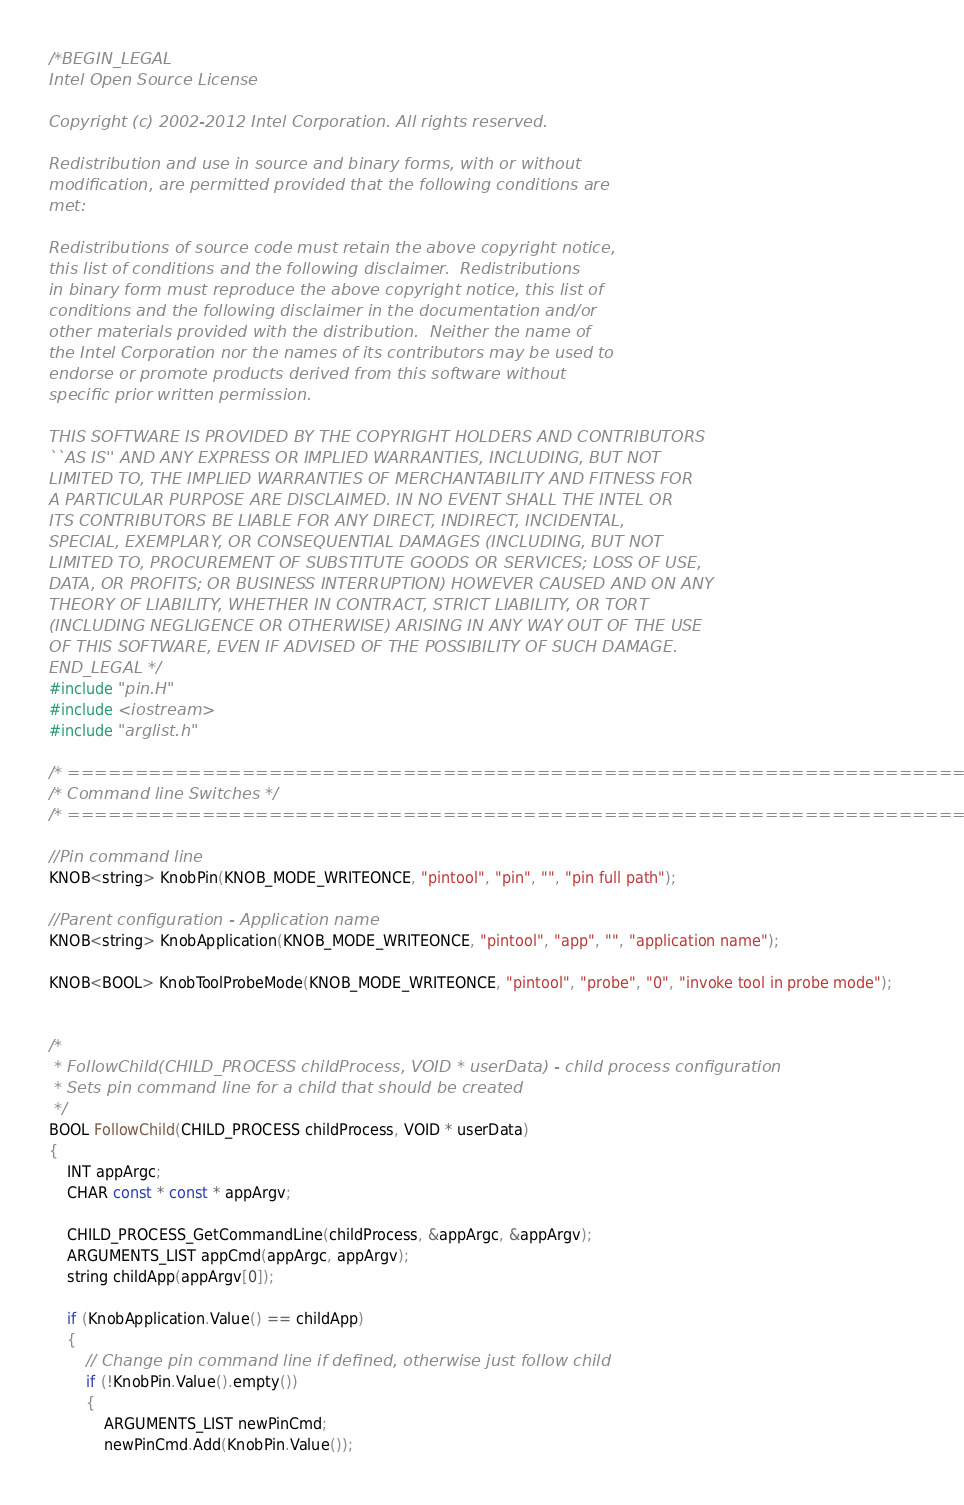<code> <loc_0><loc_0><loc_500><loc_500><_C++_>/*BEGIN_LEGAL 
Intel Open Source License 

Copyright (c) 2002-2012 Intel Corporation. All rights reserved.
 
Redistribution and use in source and binary forms, with or without
modification, are permitted provided that the following conditions are
met:

Redistributions of source code must retain the above copyright notice,
this list of conditions and the following disclaimer.  Redistributions
in binary form must reproduce the above copyright notice, this list of
conditions and the following disclaimer in the documentation and/or
other materials provided with the distribution.  Neither the name of
the Intel Corporation nor the names of its contributors may be used to
endorse or promote products derived from this software without
specific prior written permission.
 
THIS SOFTWARE IS PROVIDED BY THE COPYRIGHT HOLDERS AND CONTRIBUTORS
``AS IS'' AND ANY EXPRESS OR IMPLIED WARRANTIES, INCLUDING, BUT NOT
LIMITED TO, THE IMPLIED WARRANTIES OF MERCHANTABILITY AND FITNESS FOR
A PARTICULAR PURPOSE ARE DISCLAIMED. IN NO EVENT SHALL THE INTEL OR
ITS CONTRIBUTORS BE LIABLE FOR ANY DIRECT, INDIRECT, INCIDENTAL,
SPECIAL, EXEMPLARY, OR CONSEQUENTIAL DAMAGES (INCLUDING, BUT NOT
LIMITED TO, PROCUREMENT OF SUBSTITUTE GOODS OR SERVICES; LOSS OF USE,
DATA, OR PROFITS; OR BUSINESS INTERRUPTION) HOWEVER CAUSED AND ON ANY
THEORY OF LIABILITY, WHETHER IN CONTRACT, STRICT LIABILITY, OR TORT
(INCLUDING NEGLIGENCE OR OTHERWISE) ARISING IN ANY WAY OUT OF THE USE
OF THIS SOFTWARE, EVEN IF ADVISED OF THE POSSIBILITY OF SUCH DAMAGE.
END_LEGAL */
#include "pin.H"
#include <iostream>
#include "arglist.h"

/* ===================================================================== */
/* Command line Switches */
/* ===================================================================== */

//Pin command line
KNOB<string> KnobPin(KNOB_MODE_WRITEONCE, "pintool", "pin", "", "pin full path");

//Parent configuration - Application name
KNOB<string> KnobApplication(KNOB_MODE_WRITEONCE, "pintool", "app", "", "application name");

KNOB<BOOL> KnobToolProbeMode(KNOB_MODE_WRITEONCE, "pintool", "probe", "0", "invoke tool in probe mode");


/*
 * FollowChild(CHILD_PROCESS childProcess, VOID * userData) - child process configuration
 * Sets pin command line for a child that should be created
 */
BOOL FollowChild(CHILD_PROCESS childProcess, VOID * userData)
{
    INT appArgc;
    CHAR const * const * appArgv;

    CHILD_PROCESS_GetCommandLine(childProcess, &appArgc, &appArgv);
    ARGUMENTS_LIST appCmd(appArgc, appArgv);
    string childApp(appArgv[0]);

    if (KnobApplication.Value() == childApp)
    {
        // Change pin command line if defined, otherwise just follow child
        if (!KnobPin.Value().empty())
        {
            ARGUMENTS_LIST newPinCmd;
            newPinCmd.Add(KnobPin.Value());</code> 